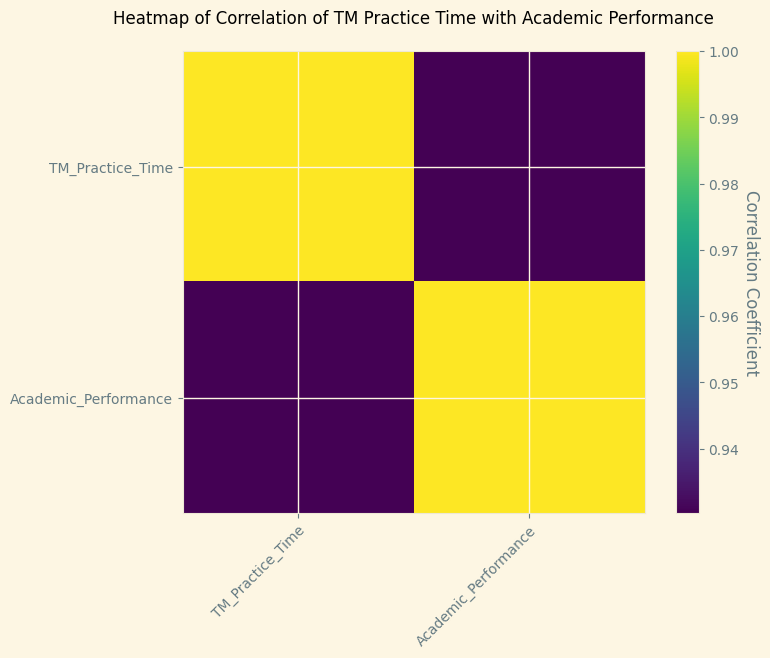What does the heatmap represent? The heatmap is a graphical representation that shows the correlation between TM Practice Time and Academic Performance. The color intensity represents the strength of the correlation coefficient.
Answer: A graphical representation of correlation Which variable shows a stronger correlation with TM Practice Time? The heatmap shows the strength of correlation for each pair of variables. Here, we only have TM Practice Time and Academic Performance. The heatmap indicates a strong positive correlation between these two variables, both variables are strongly correlated.
Answer: Both variables What does a darker color on the heatmap signify? In the heatmap, darker colors indicate higher correlation coefficients, meaning a stronger relationship between the variables.
Answer: A stronger correlation Explain the relationship observed between TM Practice Time and Academic Performance. Based on the heatmap, there is a strong positive correlation between TM Practice Time and Academic Performance, indicated by the dark color. This means that students who practice TM more tend to have higher academic performance.
Answer: Strong positive correlation Is the correlation shown on the heatmap positive or negative? The heatmap shows a positive correlation since the color representing the correlation coefficient is dark, which typically corresponds to higher, positive values.
Answer: Positive How can you tell the strength of the correlation by just looking at the heatmap? In the heatmap, the darker the color, the stronger the correlation. Since the heatmap displays very dark colors, it indicates a strong correlation.
Answer: By the darkness of the color If the color was lighter, what would that indicate about the correlation? A lighter color on the heatmap would indicate a weaker correlation coefficient, suggesting a weak or no relationship between the variables.
Answer: Weaker correlation What does a correlation coefficient of 1 signify and is it represented in this heatmap? A correlation coefficient of 1 signifies a perfect positive correlation. In the heatmap, the diagonal cells would ideally have a value of 1 because each variable is perfectly correlated with itself (TM Practice Time with TM Practice Time, Academic Performance with Academic Performance).
Answer: Perfect positive correlation; yes, on the diagonal Are both variables equally correlated with themselves in the heatmap? Yes, each variable is perfectly correlated with itself, resulting in a correlation coefficient of 1, as indicated by the darkest color on the diagonal of the heatmap.
Answer: Yes What additional information can be inferred from a higher correlation coefficient between TM Practice Time and Academic Performance? A higher correlation coefficient suggests that increases in TM Practice Time are closely related to increases in Academic Performance. It suggests a close and positive relationship where practicing more TM is associated with better academic outcomes.
Answer: Closely related increases 